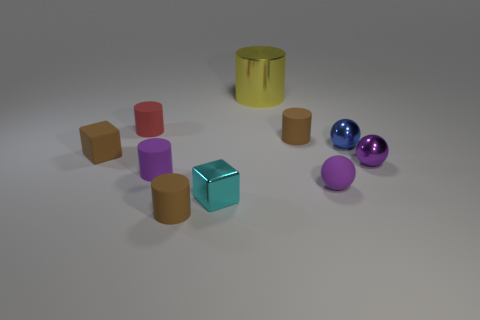Subtract all shiny cylinders. How many cylinders are left? 4 Subtract all red cylinders. How many cylinders are left? 4 Subtract all cyan cylinders. Subtract all yellow blocks. How many cylinders are left? 5 Subtract all balls. How many objects are left? 7 Add 8 tiny purple balls. How many tiny purple balls exist? 10 Subtract 1 purple cylinders. How many objects are left? 9 Subtract all tiny rubber blocks. Subtract all small matte cubes. How many objects are left? 8 Add 9 blue metallic objects. How many blue metallic objects are left? 10 